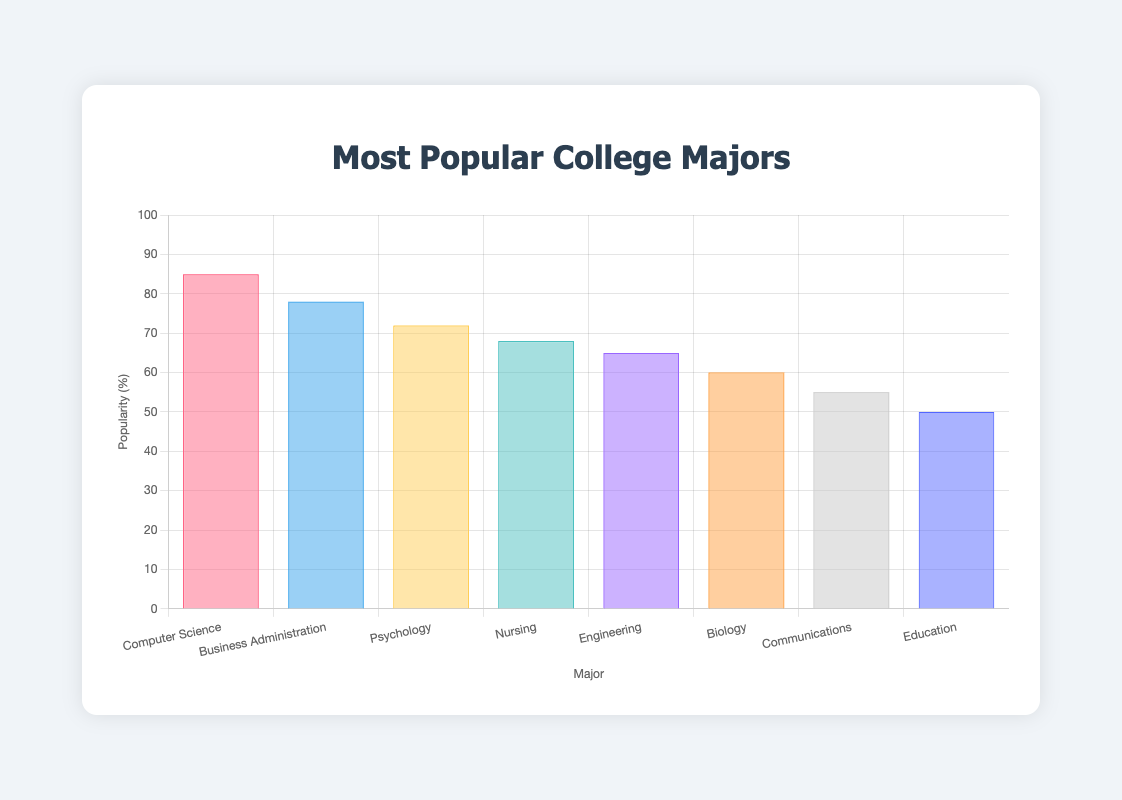What's the most popular major and its corresponding emoji? The most popular major has the highest value on the Y-axis bar. The major with the highest value is Computer Science with an 85% popularity, and the corresponding emoji is 💻.
Answer: Computer Science 💻 Which major has the lowest popularity and its associated emoji? The major with the lowest bar height on the Y-axis represents the least popular major. The major with the lowest popularity is Education with a 50% popularity and the emoji 🍎.
Answer: Education 🍎 What's the difference in popularity between Nursing and Engineering? Find the Y-axis values of Nursing and Engineering. Nursing has 68% popularity, and Engineering has 65%. Calculate the difference: 68% - 65% = 3%.
Answer: 3% What is the average popularity of all the majors combined? Sum the popularity percentages of all the majors and divide by the number of majors. The total sum is 85+78+72+68+65+60+55+50 = 533. Divide by 8 majors: 533/8 = 66.625%.
Answer: 66.625% Which majors have a popularity of more than 70% and what are their corresponding emojis? Check the Y-axis values for majors with popularity greater than 70%. The majors are Computer Science (85% 💻), Business Administration (78% 💼), and Psychology (72% 🧠).
Answer: Computer Science 💻, Business Administration 💼, Psychology 🧠 Are there more majors with popularity above or below 60%? Count the number of majors with popularity above 60% and below 60%. Above 60%: 5 majors (Computer Science, Business Administration, Psychology, Nursing, Engineering). Below 60%: 3 majors (Biology, Communications, Education). More majors are above 60%.
Answer: Above 60% What is the total popularity percentage of the top 3 majors? Sum the popularity percentages of the top 3 majors by height: Computer Science, Business Administration, and Psychology. 85% + 78% + 72% = 235%.
Answer: 235% Which major's popularity is halfway between the highest and lowest values? Calculate the halfway point between the highest (Computer Science, 85%) and lowest (Education, 50%) popularity values. Halfway is (85% + 50%) / 2 = 67.5%. Nursing (68%) is the closest to 67.5%.
Answer: Nursing What is the total number of color tones used in the bars of the chart? Count the distinct colors in the legend or bars. There are 8 distinct colors represented in the chart.
Answer: 8 